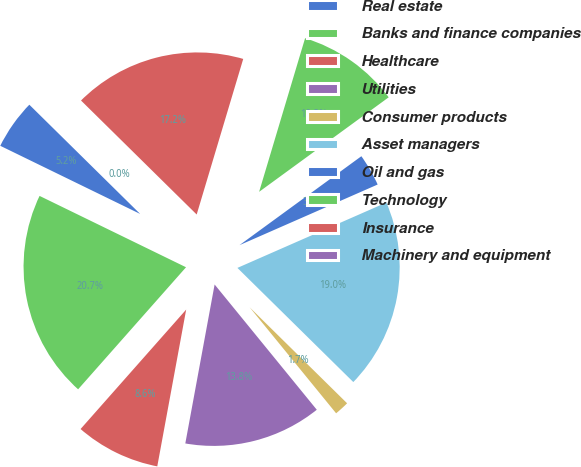Convert chart. <chart><loc_0><loc_0><loc_500><loc_500><pie_chart><fcel>Real estate<fcel>Banks and finance companies<fcel>Healthcare<fcel>Utilities<fcel>Consumer products<fcel>Asset managers<fcel>Oil and gas<fcel>Technology<fcel>Insurance<fcel>Machinery and equipment<nl><fcel>5.17%<fcel>20.69%<fcel>8.62%<fcel>13.79%<fcel>1.73%<fcel>18.96%<fcel>3.45%<fcel>10.34%<fcel>17.24%<fcel>0.0%<nl></chart> 